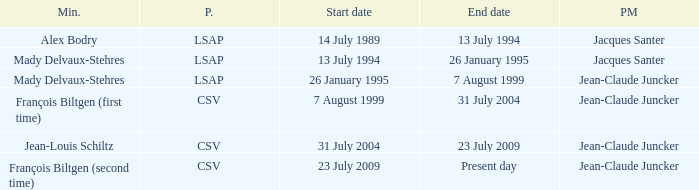Who was the minister for the CSV party with a present day end date? François Biltgen (second time). 